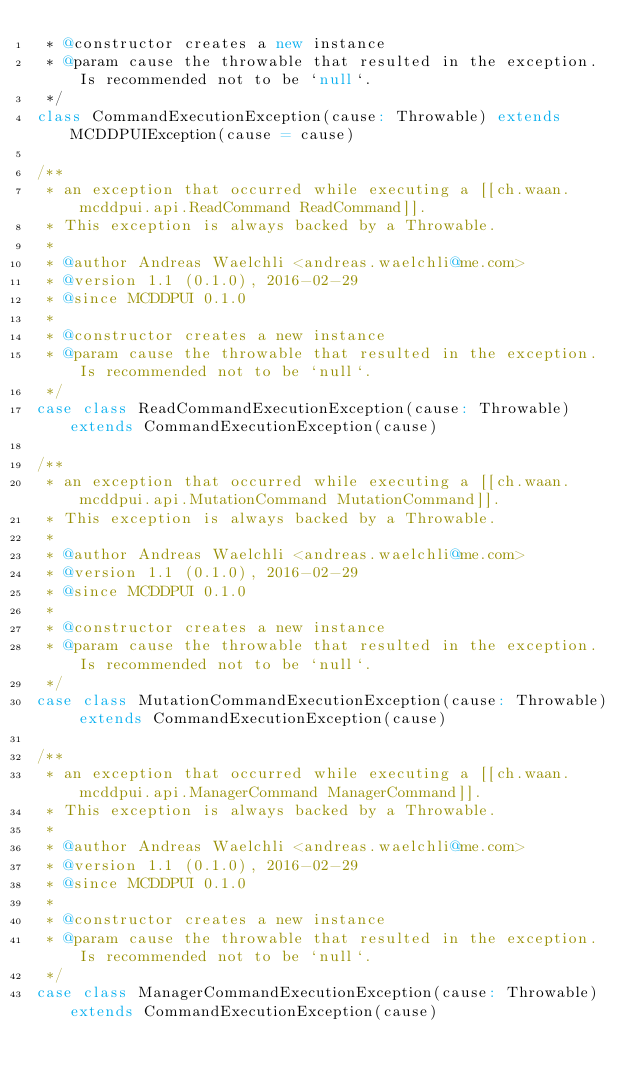Convert code to text. <code><loc_0><loc_0><loc_500><loc_500><_Scala_> * @constructor creates a new instance
 * @param cause the throwable that resulted in the exception. Is recommended not to be `null`.
 */
class CommandExecutionException(cause: Throwable) extends MCDDPUIException(cause = cause)

/**
 * an exception that occurred while executing a [[ch.waan.mcddpui.api.ReadCommand ReadCommand]].
 * This exception is always backed by a Throwable.
 *
 * @author Andreas Waelchli <andreas.waelchli@me.com>
 * @version 1.1 (0.1.0), 2016-02-29
 * @since MCDDPUI 0.1.0
 *
 * @constructor creates a new instance
 * @param cause the throwable that resulted in the exception. Is recommended not to be `null`.
 */
case class ReadCommandExecutionException(cause: Throwable) extends CommandExecutionException(cause)

/**
 * an exception that occurred while executing a [[ch.waan.mcddpui.api.MutationCommand MutationCommand]].
 * This exception is always backed by a Throwable.
 *
 * @author Andreas Waelchli <andreas.waelchli@me.com>
 * @version 1.1 (0.1.0), 2016-02-29
 * @since MCDDPUI 0.1.0
 *
 * @constructor creates a new instance
 * @param cause the throwable that resulted in the exception. Is recommended not to be `null`.
 */
case class MutationCommandExecutionException(cause: Throwable) extends CommandExecutionException(cause)

/**
 * an exception that occurred while executing a [[ch.waan.mcddpui.api.ManagerCommand ManagerCommand]].
 * This exception is always backed by a Throwable.
 *
 * @author Andreas Waelchli <andreas.waelchli@me.com>
 * @version 1.1 (0.1.0), 2016-02-29
 * @since MCDDPUI 0.1.0
 *
 * @constructor creates a new instance
 * @param cause the throwable that resulted in the exception. Is recommended not to be `null`.
 */
case class ManagerCommandExecutionException(cause: Throwable) extends CommandExecutionException(cause)</code> 